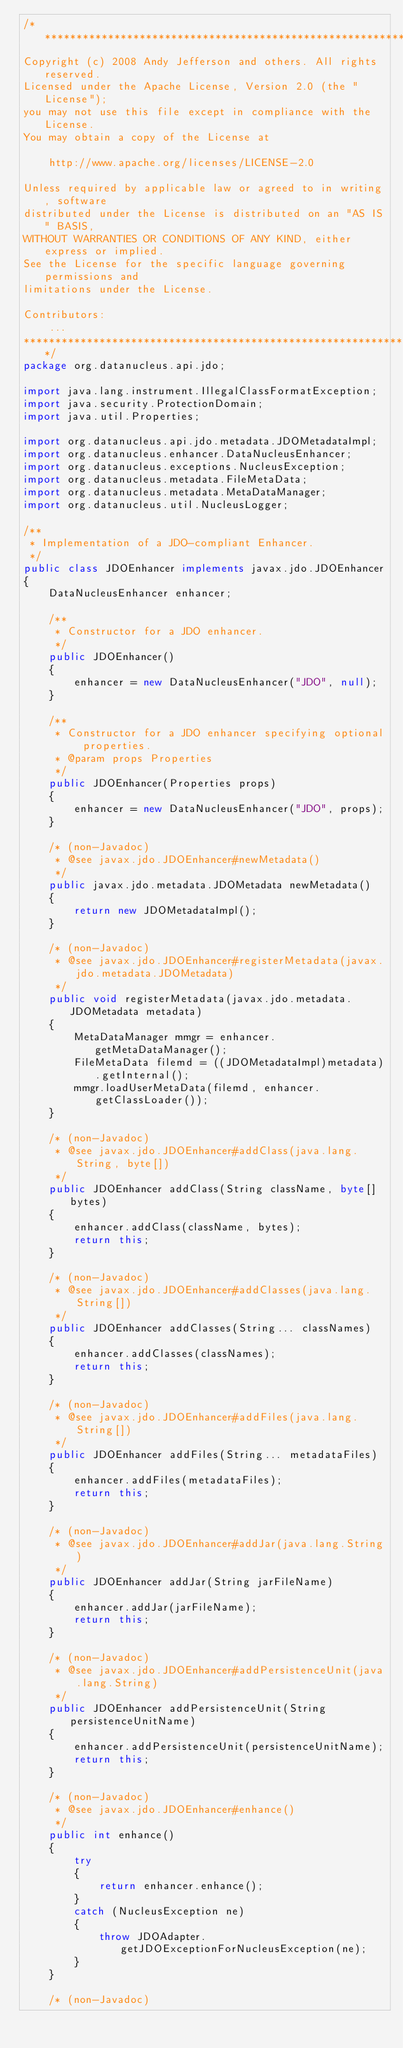Convert code to text. <code><loc_0><loc_0><loc_500><loc_500><_Java_>/**********************************************************************
Copyright (c) 2008 Andy Jefferson and others. All rights reserved.
Licensed under the Apache License, Version 2.0 (the "License");
you may not use this file except in compliance with the License.
You may obtain a copy of the License at

    http://www.apache.org/licenses/LICENSE-2.0

Unless required by applicable law or agreed to in writing, software
distributed under the License is distributed on an "AS IS" BASIS,
WITHOUT WARRANTIES OR CONDITIONS OF ANY KIND, either express or implied.
See the License for the specific language governing permissions and
limitations under the License.

Contributors:
    ...
**********************************************************************/
package org.datanucleus.api.jdo;

import java.lang.instrument.IllegalClassFormatException;
import java.security.ProtectionDomain;
import java.util.Properties;

import org.datanucleus.api.jdo.metadata.JDOMetadataImpl;
import org.datanucleus.enhancer.DataNucleusEnhancer;
import org.datanucleus.exceptions.NucleusException;
import org.datanucleus.metadata.FileMetaData;
import org.datanucleus.metadata.MetaDataManager;
import org.datanucleus.util.NucleusLogger;

/**
 * Implementation of a JDO-compliant Enhancer.
 */
public class JDOEnhancer implements javax.jdo.JDOEnhancer
{
    DataNucleusEnhancer enhancer;

    /**
     * Constructor for a JDO enhancer.
     */
    public JDOEnhancer()
    {
        enhancer = new DataNucleusEnhancer("JDO", null);
    }

    /**
     * Constructor for a JDO enhancer specifying optional properties.
     * @param props Properties
     */
    public JDOEnhancer(Properties props)
    {
        enhancer = new DataNucleusEnhancer("JDO", props);
    }

    /* (non-Javadoc)
     * @see javax.jdo.JDOEnhancer#newMetadata()
     */
    public javax.jdo.metadata.JDOMetadata newMetadata()
    {
        return new JDOMetadataImpl();
    }

    /* (non-Javadoc)
     * @see javax.jdo.JDOEnhancer#registerMetadata(javax.jdo.metadata.JDOMetadata)
     */
    public void registerMetadata(javax.jdo.metadata.JDOMetadata metadata)
    {
        MetaDataManager mmgr = enhancer.getMetaDataManager();
        FileMetaData filemd = ((JDOMetadataImpl)metadata).getInternal();
        mmgr.loadUserMetaData(filemd, enhancer.getClassLoader());
    }

    /* (non-Javadoc)
     * @see javax.jdo.JDOEnhancer#addClass(java.lang.String, byte[])
     */
    public JDOEnhancer addClass(String className, byte[] bytes)
    {
        enhancer.addClass(className, bytes);
        return this;
    }

    /* (non-Javadoc)
     * @see javax.jdo.JDOEnhancer#addClasses(java.lang.String[])
     */
    public JDOEnhancer addClasses(String... classNames)
    {
        enhancer.addClasses(classNames);
        return this;
    }

    /* (non-Javadoc)
     * @see javax.jdo.JDOEnhancer#addFiles(java.lang.String[])
     */
    public JDOEnhancer addFiles(String... metadataFiles)
    {
        enhancer.addFiles(metadataFiles);
        return this;
    }

    /* (non-Javadoc)
     * @see javax.jdo.JDOEnhancer#addJar(java.lang.String)
     */
    public JDOEnhancer addJar(String jarFileName)
    {
        enhancer.addJar(jarFileName);
        return this;
    }

    /* (non-Javadoc)
     * @see javax.jdo.JDOEnhancer#addPersistenceUnit(java.lang.String)
     */
    public JDOEnhancer addPersistenceUnit(String persistenceUnitName)
    {
        enhancer.addPersistenceUnit(persistenceUnitName);
        return this;
    }

    /* (non-Javadoc)
     * @see javax.jdo.JDOEnhancer#enhance()
     */
    public int enhance()
    {
        try
        {
            return enhancer.enhance();
        }
        catch (NucleusException ne)
        {
            throw JDOAdapter.getJDOExceptionForNucleusException(ne);
        }
    }

    /* (non-Javadoc)</code> 